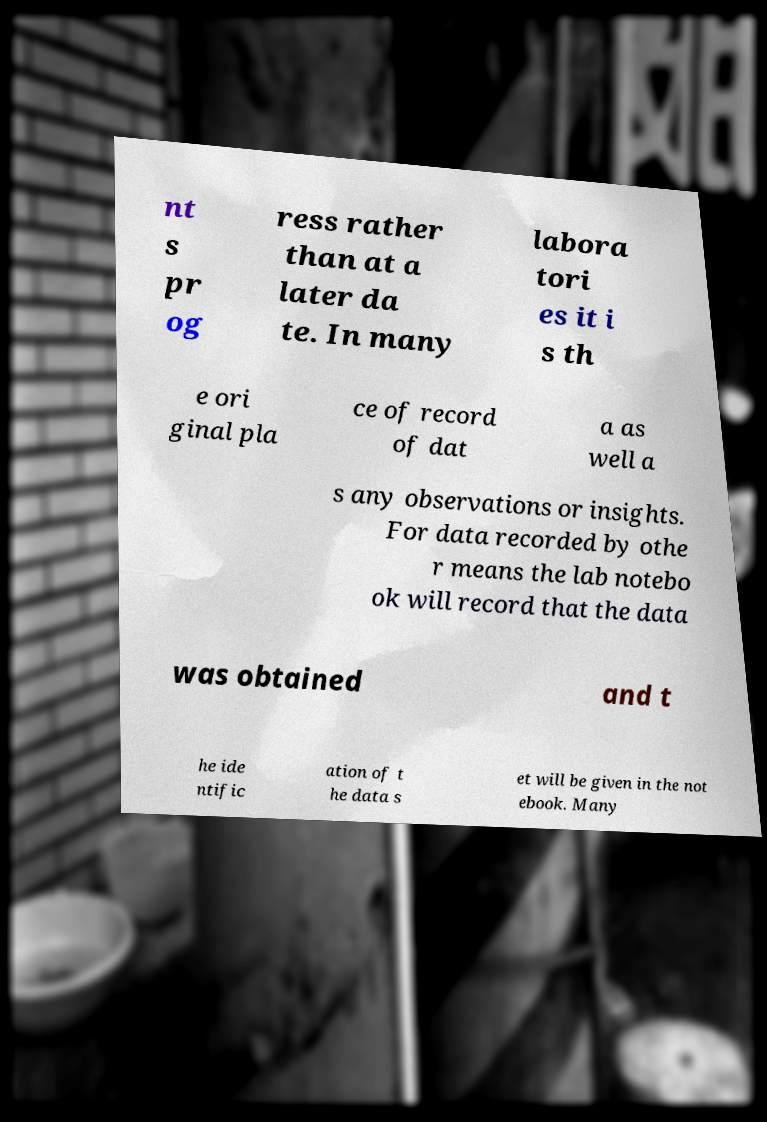What messages or text are displayed in this image? I need them in a readable, typed format. nt s pr og ress rather than at a later da te. In many labora tori es it i s th e ori ginal pla ce of record of dat a as well a s any observations or insights. For data recorded by othe r means the lab notebo ok will record that the data was obtained and t he ide ntific ation of t he data s et will be given in the not ebook. Many 